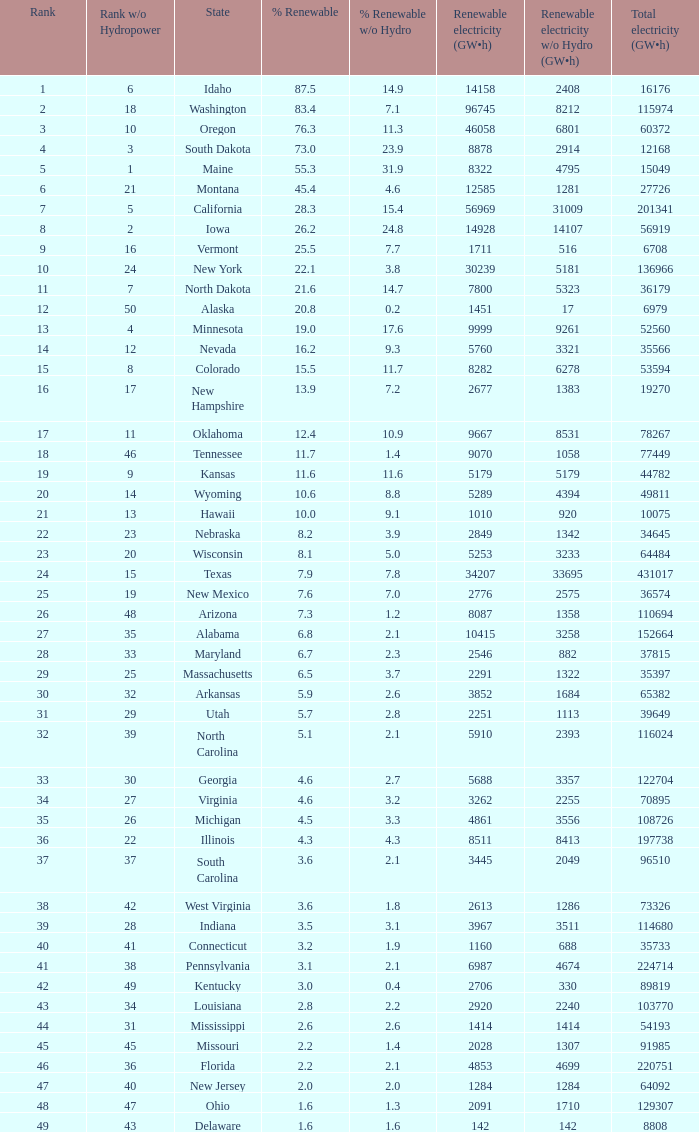What is the proportion of renewable electricity excluding hydrogen power in south dakota? 23.9. 